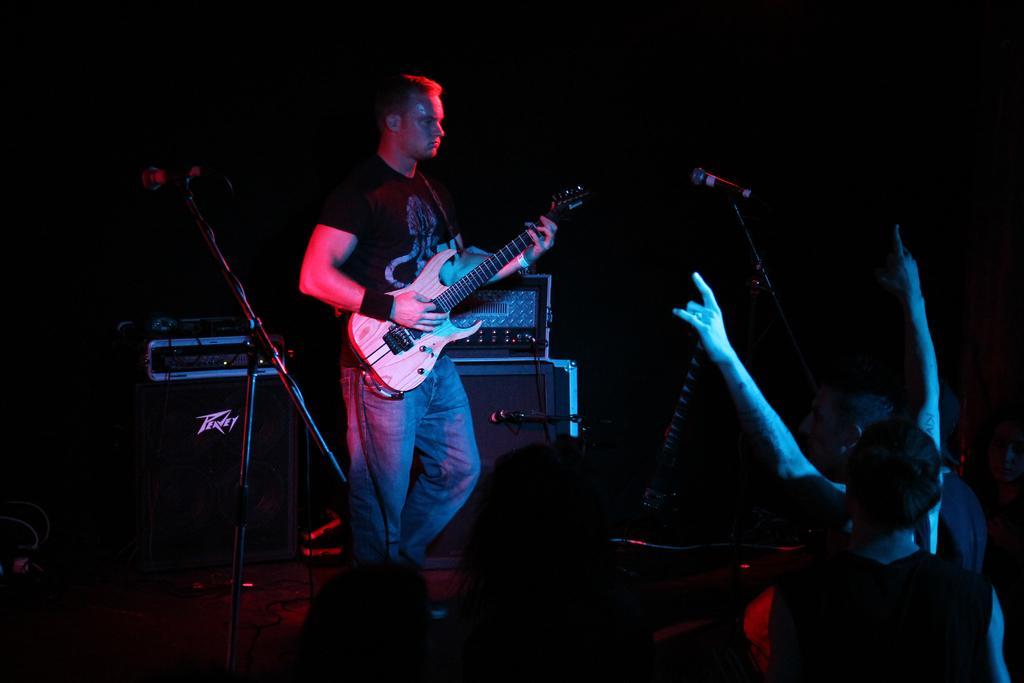In one or two sentences, can you explain what this image depicts? In this image i can see a person wearing a black t shirt and blue jeans is standing and holding a guitar. i can see few microphones and few people in front of him. In the background i can see few speakers,a musical system and a black cloth. 